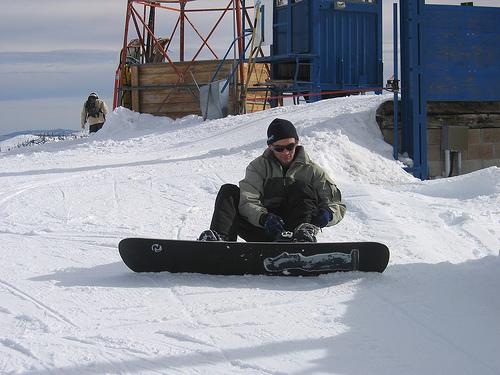Identify at least two objects in the background and describe them briefly. There is a blue and black glove on the right hand of the man and an electrical box attached to a short cinder block wall. How is the weather in the image? The weather in the image is light blue and partly cloudy. Mention at least three objects in the picture and describe their appearance. There is a black snowboard with a design on the bottom, a man wearing dark sunglasses, and a blue partly cloudy sky. Describe the entirety of the man's outfit, including what he is wearing on his face. The man is wearing a grey jacket, black pants, black hat with a white design, dark sunglasses, and blue and black gloves. What is the man wearing on his head, and how would you describe it? The man is wearing a black hat with a white design on the right side. Point out the main activity of the person in the image and describe their attire. The man is attaching a snowboard to his boots while wearing a grey jacket, black pants, sunglasses, and a black hat with a white design. State the position of the man with respect to the snow. The man is sitting on the snow. Examine the image and mention the type of gloves the man is wearing based on their color. The man is wearing blue and black gloves on his hands. State the primary color of the man's pants. The man's pants are black. What is the color and design of the snowboard featured in the image? The snowboard is black in color with a design on the bottom. Is there a person in the background of the image? Yes Which objects are present in the man's face? Sunglasses, black hat, and nose Mention an element in the background. Blue buildings What can you infer about the weather? Partly cloudy and cold Where is the snowman that the man on the snowboard is looking at? No, it's not mentioned in the image. What is the man doing with the snowboard? Attaching it to his boots What is the color of the man's gloves? Blue and black What is the state of the sky? Light blue and partly cloudy Describe the location of the electrical box. Attached to a short cinder block wall Is the man wearing sunglasses, a hat or both? Both There's a dog playing with a green ball near the snowboarder. Locate the dog and describe its actions. This instruction is written in a declarative sentence implying the existence of a dog, which is not mentioned in the list of objects. The user is asked to describe the actions of a non-existent object, making the instruction misleading. Identify an activity the man is involved in. Attaching snowboard to boots What is happening in the far background? A mountain is present Specify the type and color of the man's headgear. Black hat with a white design on the right side Choose one object and describe its characteristics. Sunglasses - dark colored and worn by the man What color are the man's pants? Black Which of the following options is true about the snowboard? - It has a design on the bottom Describe the man's jacket. Light and dark gray coat 